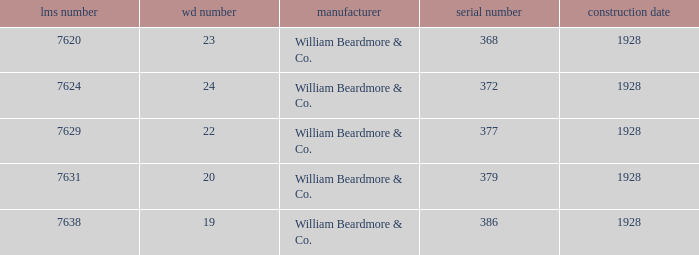Name the builder for wd number being 22 William Beardmore & Co. 